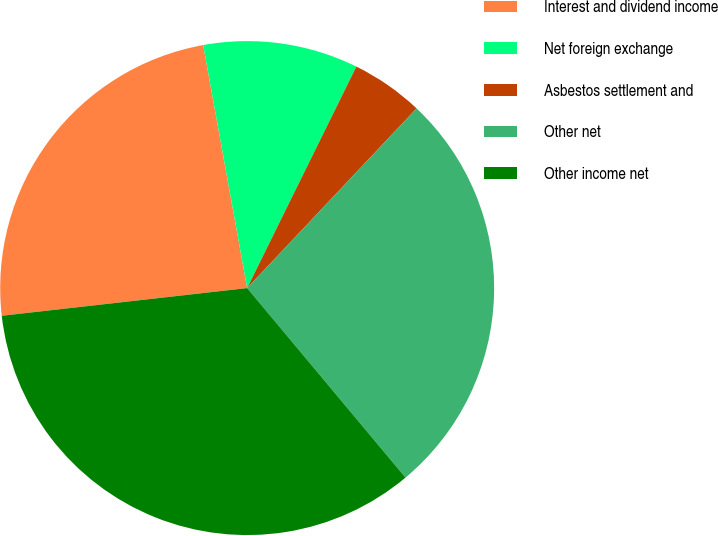Convert chart. <chart><loc_0><loc_0><loc_500><loc_500><pie_chart><fcel>Interest and dividend income<fcel>Net foreign exchange<fcel>Asbestos settlement and<fcel>Other net<fcel>Other income net<nl><fcel>23.94%<fcel>10.14%<fcel>4.74%<fcel>26.89%<fcel>34.29%<nl></chart> 